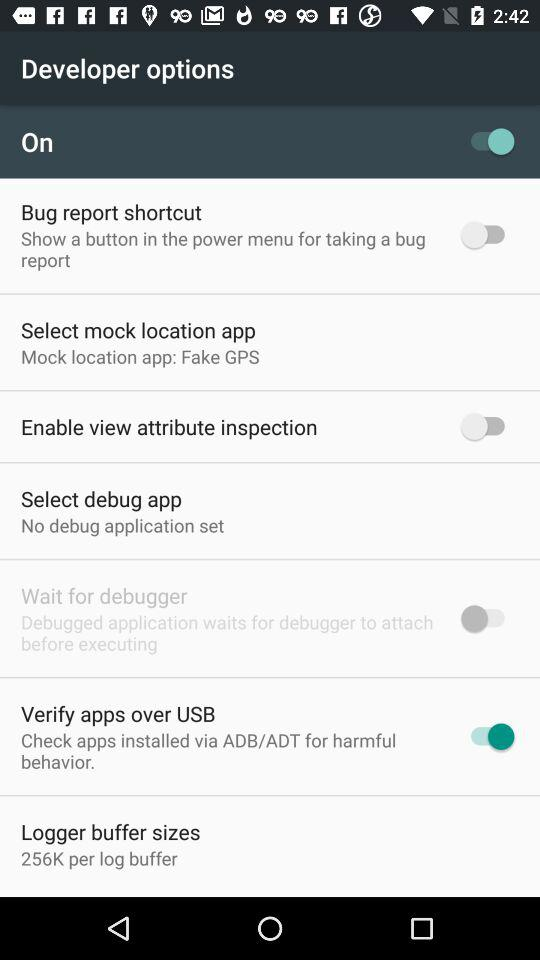What is the size of the log buffer? The size of the log buffer is 256K. 